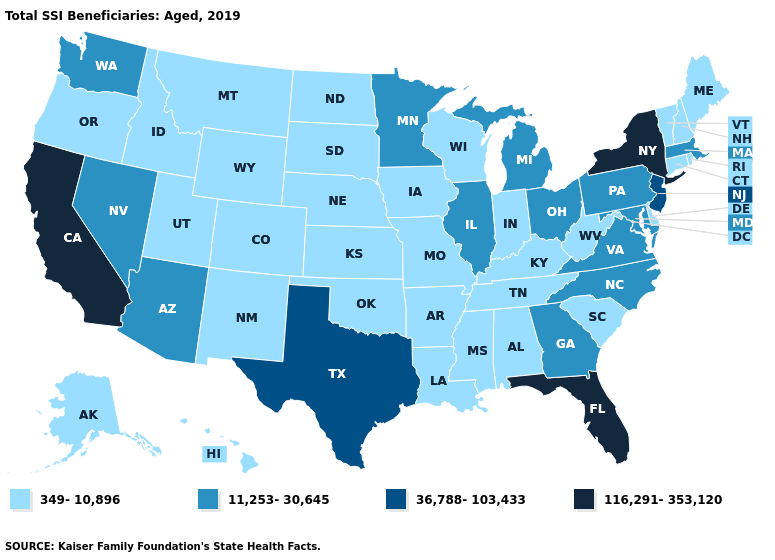Which states have the lowest value in the USA?
Concise answer only. Alabama, Alaska, Arkansas, Colorado, Connecticut, Delaware, Hawaii, Idaho, Indiana, Iowa, Kansas, Kentucky, Louisiana, Maine, Mississippi, Missouri, Montana, Nebraska, New Hampshire, New Mexico, North Dakota, Oklahoma, Oregon, Rhode Island, South Carolina, South Dakota, Tennessee, Utah, Vermont, West Virginia, Wisconsin, Wyoming. Does Kentucky have the lowest value in the USA?
Answer briefly. Yes. What is the highest value in states that border Indiana?
Quick response, please. 11,253-30,645. Which states have the lowest value in the West?
Short answer required. Alaska, Colorado, Hawaii, Idaho, Montana, New Mexico, Oregon, Utah, Wyoming. Among the states that border Florida , which have the highest value?
Keep it brief. Georgia. Does the first symbol in the legend represent the smallest category?
Write a very short answer. Yes. Does Georgia have a lower value than New York?
Short answer required. Yes. Name the states that have a value in the range 36,788-103,433?
Give a very brief answer. New Jersey, Texas. Name the states that have a value in the range 349-10,896?
Be succinct. Alabama, Alaska, Arkansas, Colorado, Connecticut, Delaware, Hawaii, Idaho, Indiana, Iowa, Kansas, Kentucky, Louisiana, Maine, Mississippi, Missouri, Montana, Nebraska, New Hampshire, New Mexico, North Dakota, Oklahoma, Oregon, Rhode Island, South Carolina, South Dakota, Tennessee, Utah, Vermont, West Virginia, Wisconsin, Wyoming. Does Arkansas have the same value as Wyoming?
Concise answer only. Yes. Name the states that have a value in the range 36,788-103,433?
Answer briefly. New Jersey, Texas. What is the lowest value in the USA?
Answer briefly. 349-10,896. Name the states that have a value in the range 349-10,896?
Keep it brief. Alabama, Alaska, Arkansas, Colorado, Connecticut, Delaware, Hawaii, Idaho, Indiana, Iowa, Kansas, Kentucky, Louisiana, Maine, Mississippi, Missouri, Montana, Nebraska, New Hampshire, New Mexico, North Dakota, Oklahoma, Oregon, Rhode Island, South Carolina, South Dakota, Tennessee, Utah, Vermont, West Virginia, Wisconsin, Wyoming. What is the value of Colorado?
Keep it brief. 349-10,896. Name the states that have a value in the range 116,291-353,120?
Be succinct. California, Florida, New York. 